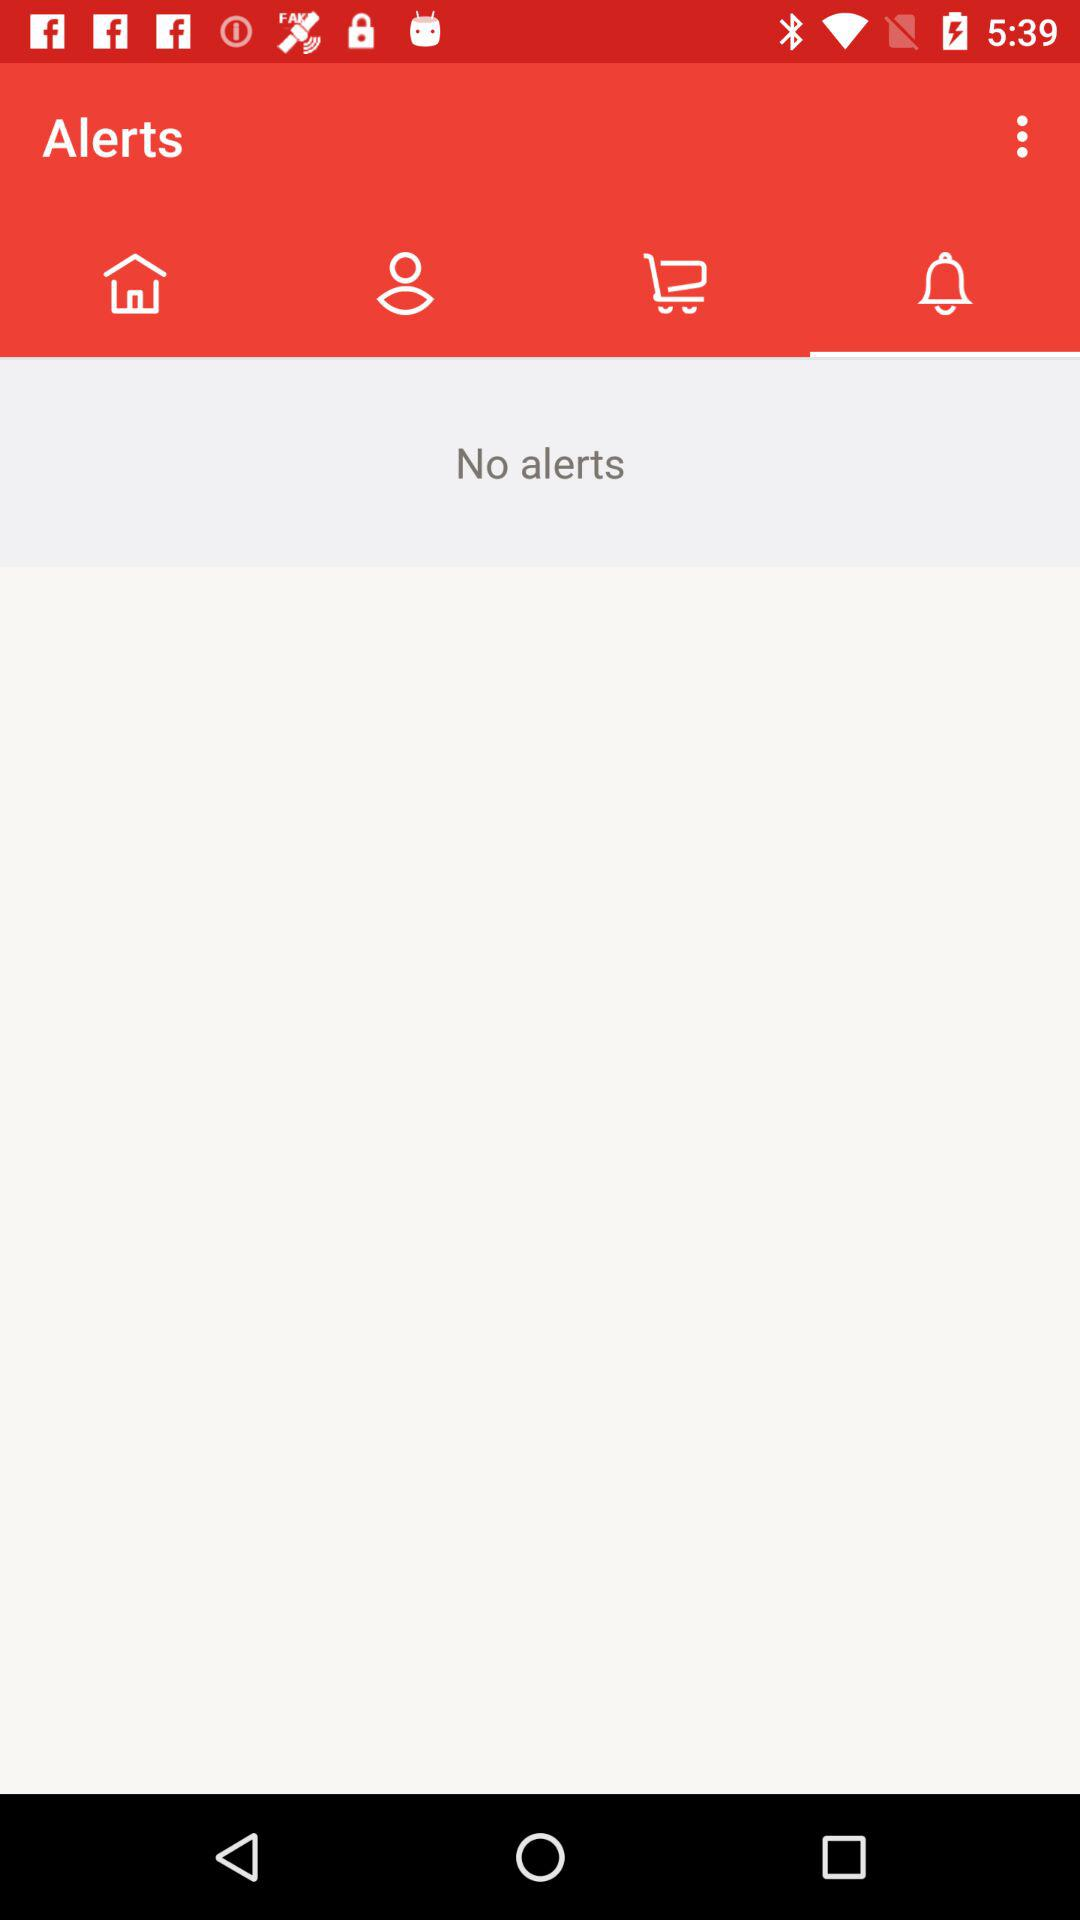Are there any alerts? There are no alerts. 